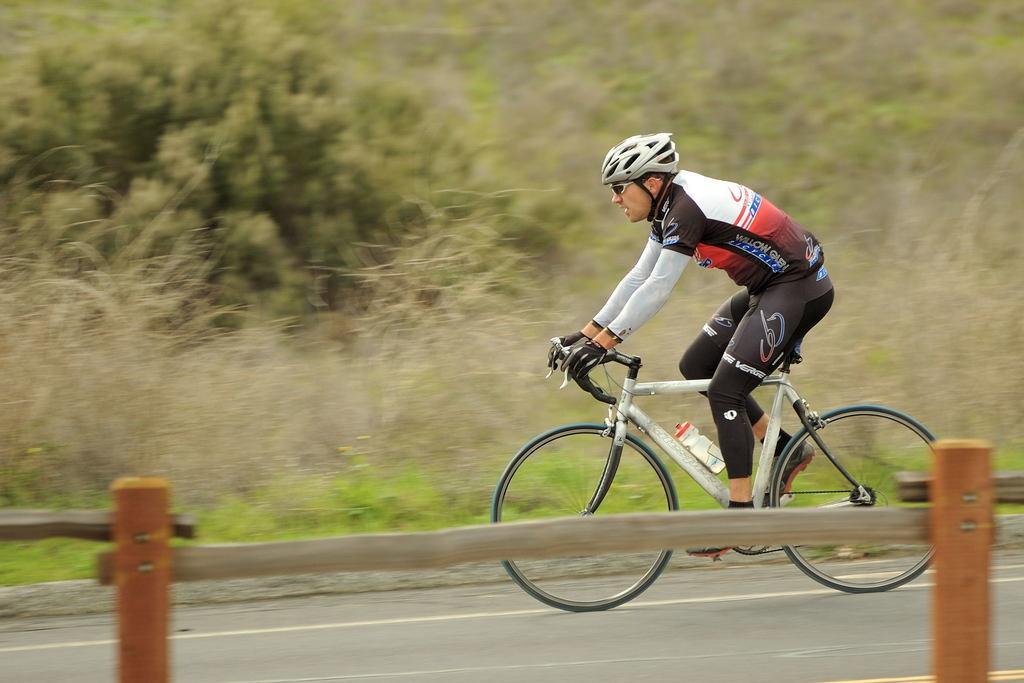In one or two sentences, can you explain what this image depicts? In this picture we can see a person riding bicycle, this person wore a helmet, goggles, gloves and shoes, in the background we can see trees. 